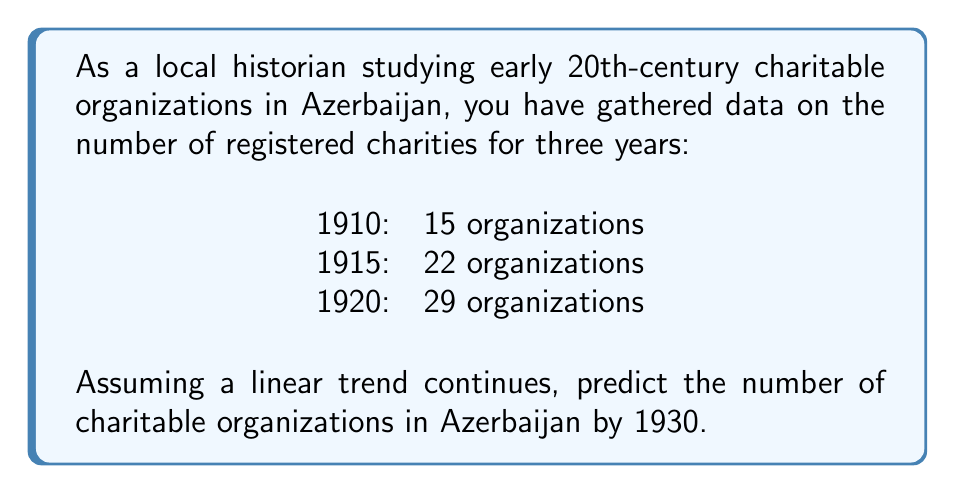Solve this math problem. To predict the number of charitable organizations in 1930 using a linear trend, we need to follow these steps:

1. Calculate the rate of change (slope) between each data point:
   From 1910 to 1915: $\frac{22 - 15}{1915 - 1910} = \frac{7}{5} = 1.4$ organizations per year
   From 1915 to 1920: $\frac{29 - 22}{1920 - 1915} = \frac{7}{5} = 1.4$ organizations per year

   The consistent rate of change confirms a linear trend.

2. Use the point-slope form of a linear equation:
   $y - y_1 = m(x - x_1)$
   Where $m$ is the slope, $(x_1, y_1)$ is a known point, $x$ is the input year, and $y$ is the number of organizations.

3. Let's use the 1920 data point $(1920, 29)$ and solve for $y$:
   $y - 29 = 1.4(x - 1920)$
   $y = 1.4(x - 1920) + 29$
   $y = 1.4x - 2659$

4. To predict the number of organizations in 1930, substitute $x = 1930$:
   $y = 1.4(1930) - 2659$
   $y = 2702 - 2659$
   $y = 43$

Therefore, based on the linear trend, we predict there will be 43 charitable organizations in Azerbaijan by 1930.
Answer: 43 charitable organizations 